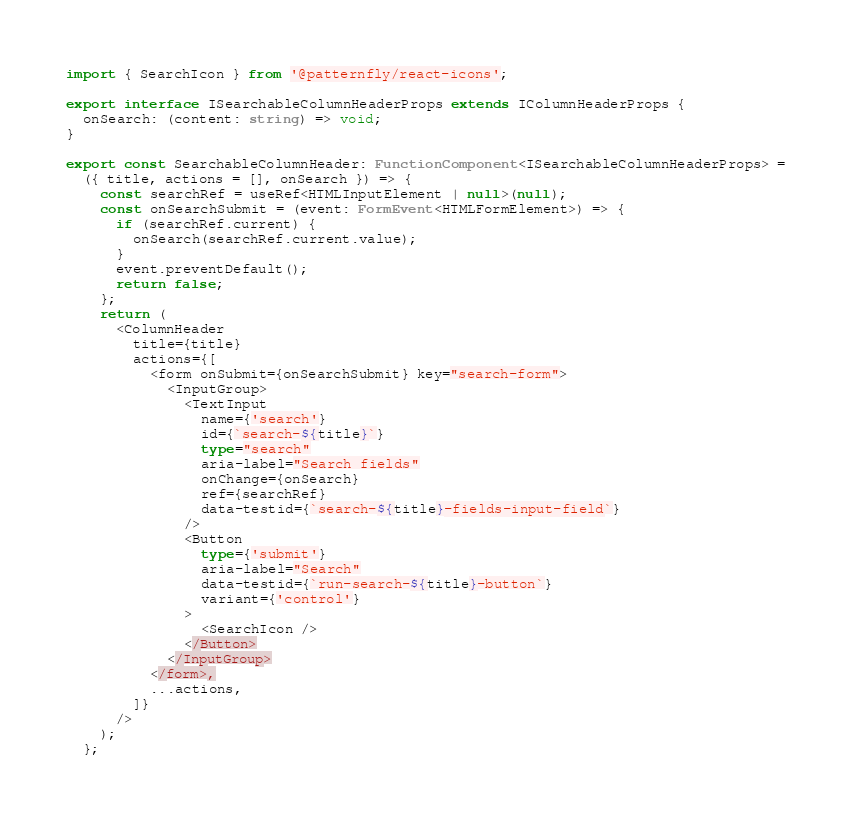Convert code to text. <code><loc_0><loc_0><loc_500><loc_500><_TypeScript_>
import { SearchIcon } from '@patternfly/react-icons';

export interface ISearchableColumnHeaderProps extends IColumnHeaderProps {
  onSearch: (content: string) => void;
}

export const SearchableColumnHeader: FunctionComponent<ISearchableColumnHeaderProps> =
  ({ title, actions = [], onSearch }) => {
    const searchRef = useRef<HTMLInputElement | null>(null);
    const onSearchSubmit = (event: FormEvent<HTMLFormElement>) => {
      if (searchRef.current) {
        onSearch(searchRef.current.value);
      }
      event.preventDefault();
      return false;
    };
    return (
      <ColumnHeader
        title={title}
        actions={[
          <form onSubmit={onSearchSubmit} key="search-form">
            <InputGroup>
              <TextInput
                name={'search'}
                id={`search-${title}`}
                type="search"
                aria-label="Search fields"
                onChange={onSearch}
                ref={searchRef}
                data-testid={`search-${title}-fields-input-field`}
              />
              <Button
                type={'submit'}
                aria-label="Search"
                data-testid={`run-search-${title}-button`}
                variant={'control'}
              >
                <SearchIcon />
              </Button>
            </InputGroup>
          </form>,
          ...actions,
        ]}
      />
    );
  };
</code> 